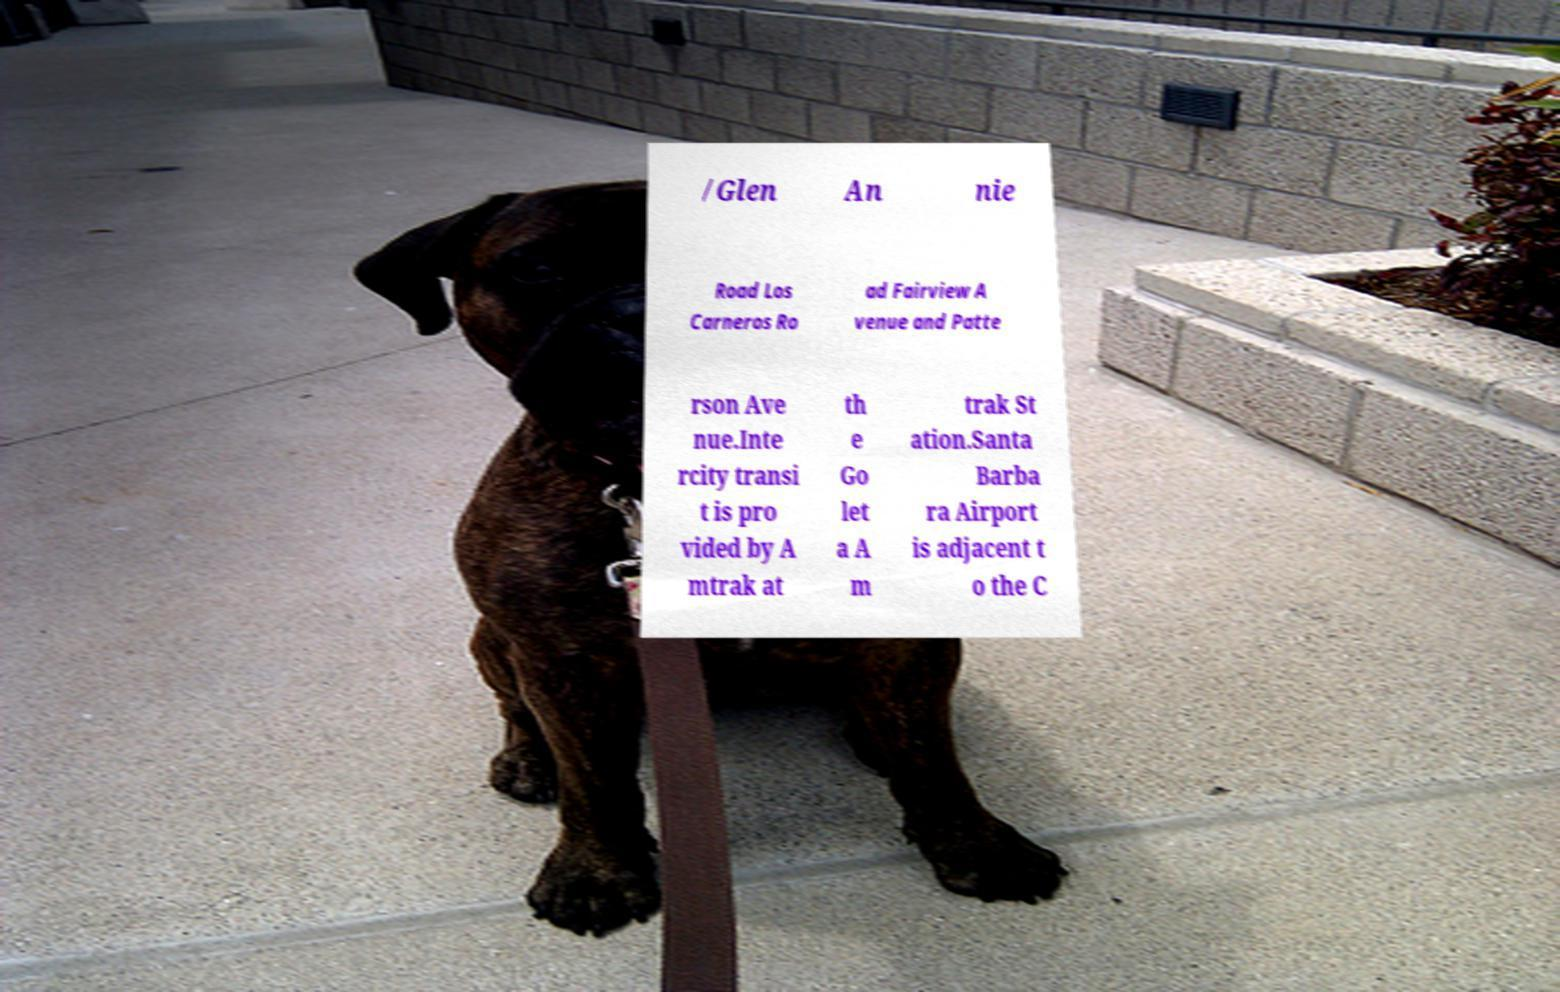Could you extract and type out the text from this image? /Glen An nie Road Los Carneros Ro ad Fairview A venue and Patte rson Ave nue.Inte rcity transi t is pro vided by A mtrak at th e Go let a A m trak St ation.Santa Barba ra Airport is adjacent t o the C 